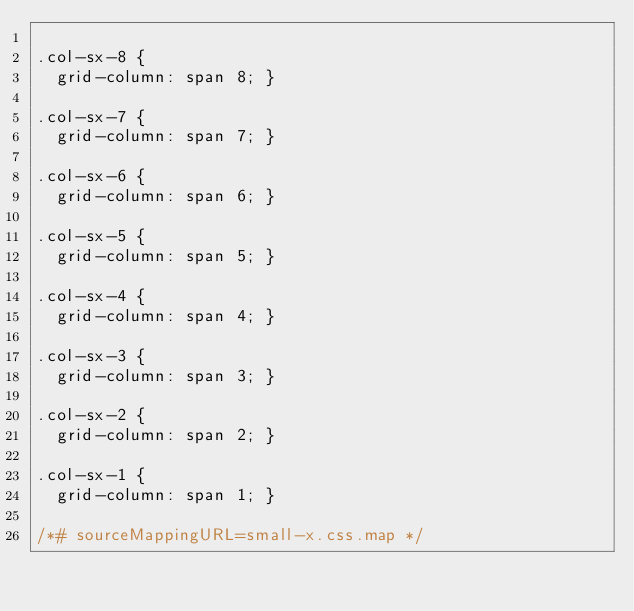<code> <loc_0><loc_0><loc_500><loc_500><_CSS_>
.col-sx-8 {
  grid-column: span 8; }

.col-sx-7 {
  grid-column: span 7; }

.col-sx-6 {
  grid-column: span 6; }

.col-sx-5 {
  grid-column: span 5; }

.col-sx-4 {
  grid-column: span 4; }

.col-sx-3 {
  grid-column: span 3; }

.col-sx-2 {
  grid-column: span 2; }

.col-sx-1 {
  grid-column: span 1; }

/*# sourceMappingURL=small-x.css.map */
</code> 